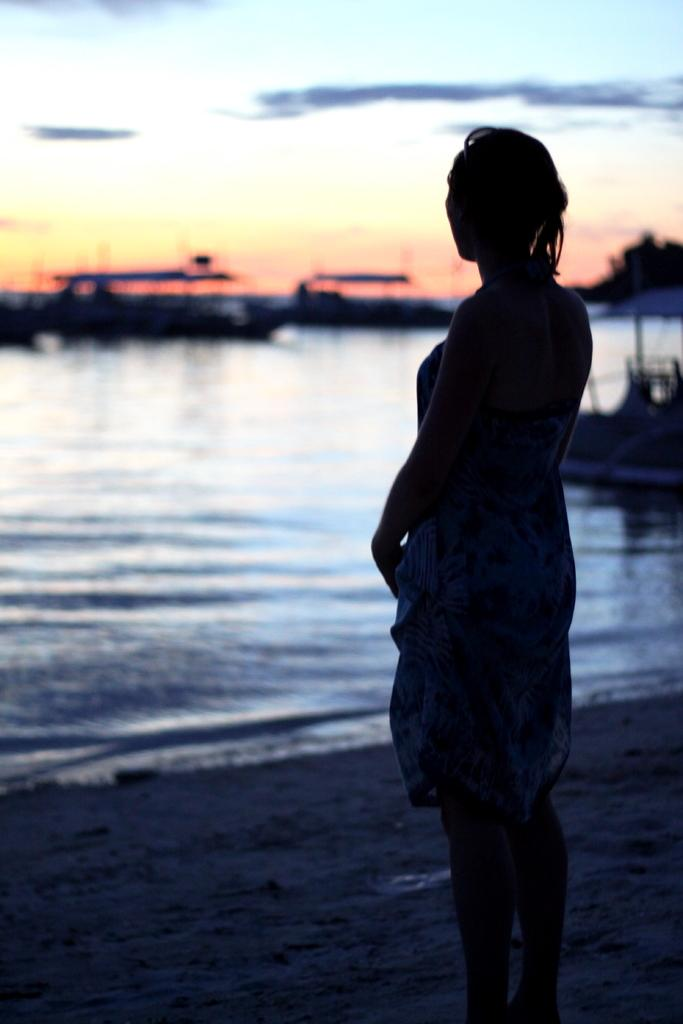Who is present in the image? There is a woman in the image. What is the woman doing in the image? The woman is standing in the image. What can be seen on the water in the image? There are boats on the water in the image. How are the boats positioned in relation to the woman? The boats are in front of the woman in the image. What is visible in the background of the image? There is a sky visible in the image. What type of berry is being used to decorate the street in the image? There is no berry or street present in the image; it features a woman standing with boats in front of her and a visible sky. 